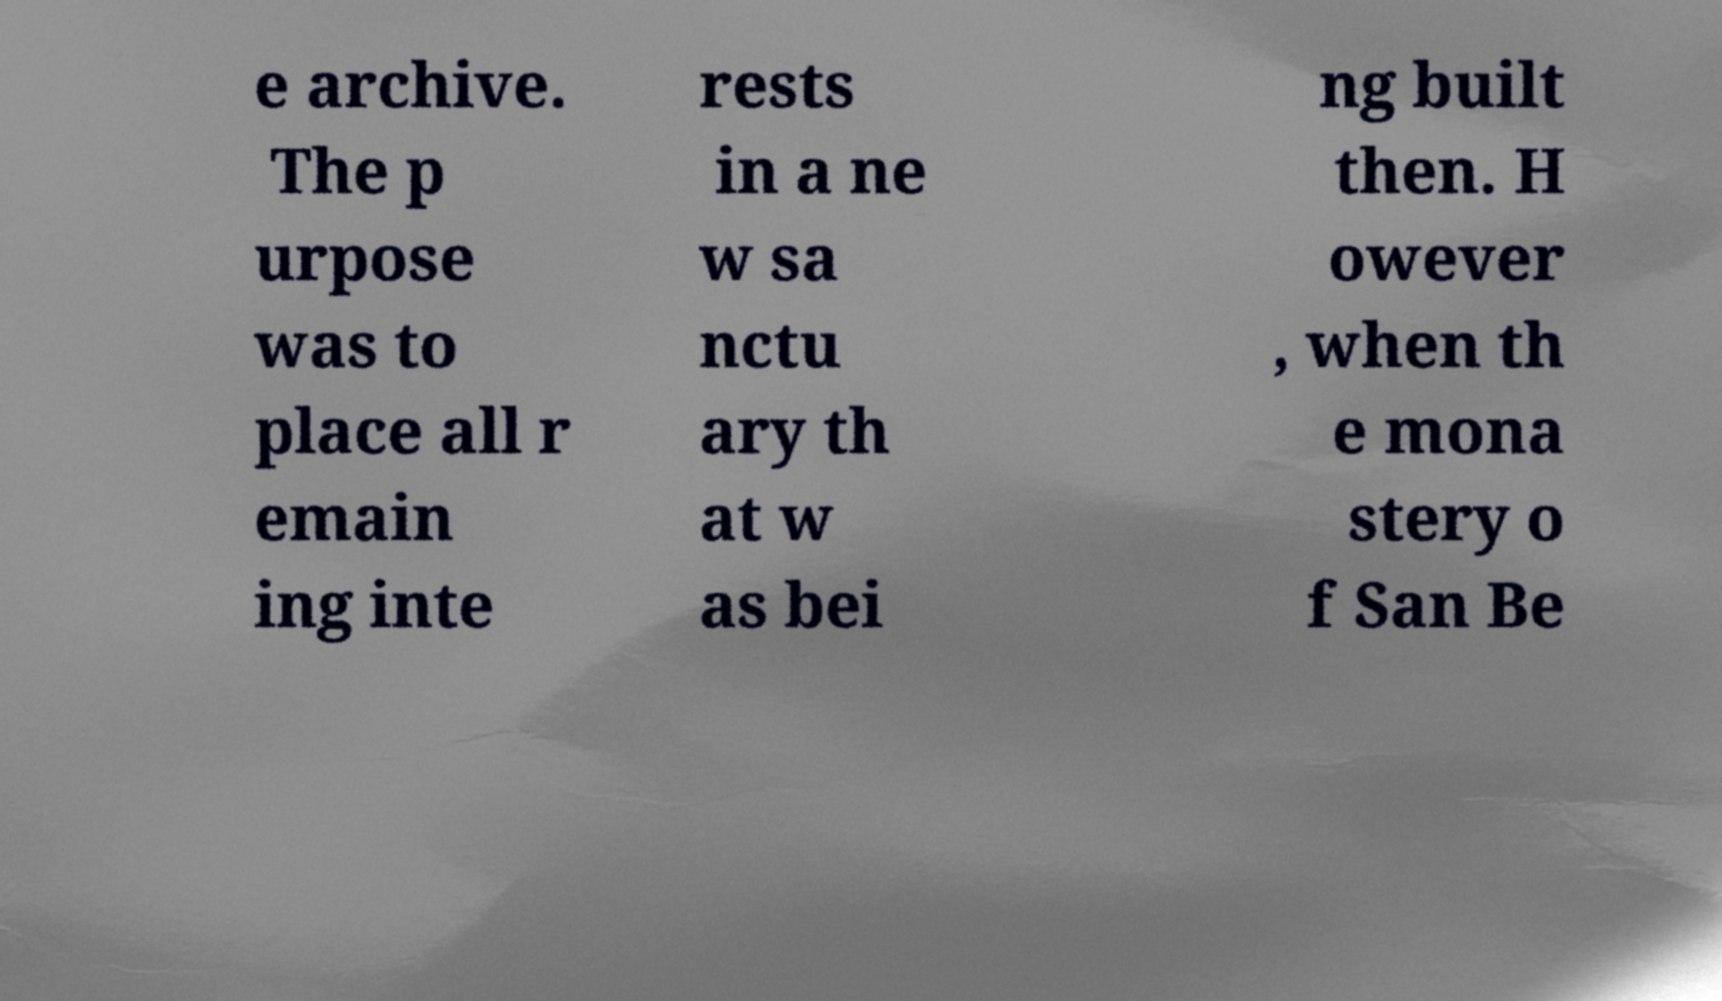I need the written content from this picture converted into text. Can you do that? e archive. The p urpose was to place all r emain ing inte rests in a ne w sa nctu ary th at w as bei ng built then. H owever , when th e mona stery o f San Be 